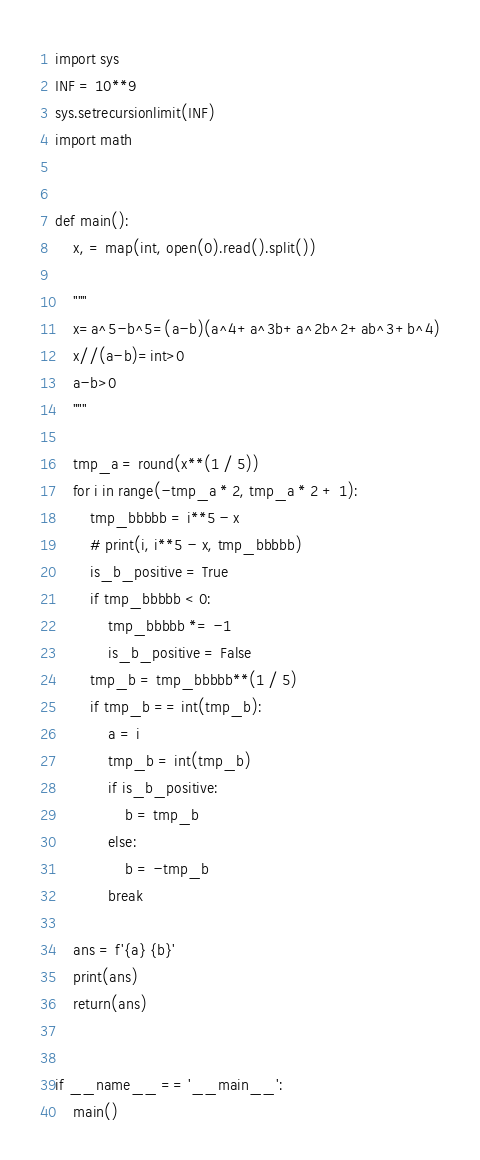Convert code to text. <code><loc_0><loc_0><loc_500><loc_500><_Python_>import sys
INF = 10**9
sys.setrecursionlimit(INF)
import math


def main():
    x, = map(int, open(0).read().split())

    """
    x=a^5-b^5=(a-b)(a^4+a^3b+a^2b^2+ab^3+b^4)
    x//(a-b)=int>0
    a-b>0
    """

    tmp_a = round(x**(1 / 5))
    for i in range(-tmp_a * 2, tmp_a * 2 + 1):
        tmp_bbbbb = i**5 - x
        # print(i, i**5 - x, tmp_bbbbb)
        is_b_positive = True
        if tmp_bbbbb < 0:
            tmp_bbbbb *= -1
            is_b_positive = False
        tmp_b = tmp_bbbbb**(1 / 5)
        if tmp_b == int(tmp_b):
            a = i
            tmp_b = int(tmp_b)
            if is_b_positive:
                b = tmp_b
            else:
                b = -tmp_b
            break

    ans = f'{a} {b}'
    print(ans)
    return(ans)


if __name__ == '__main__':
    main()
</code> 